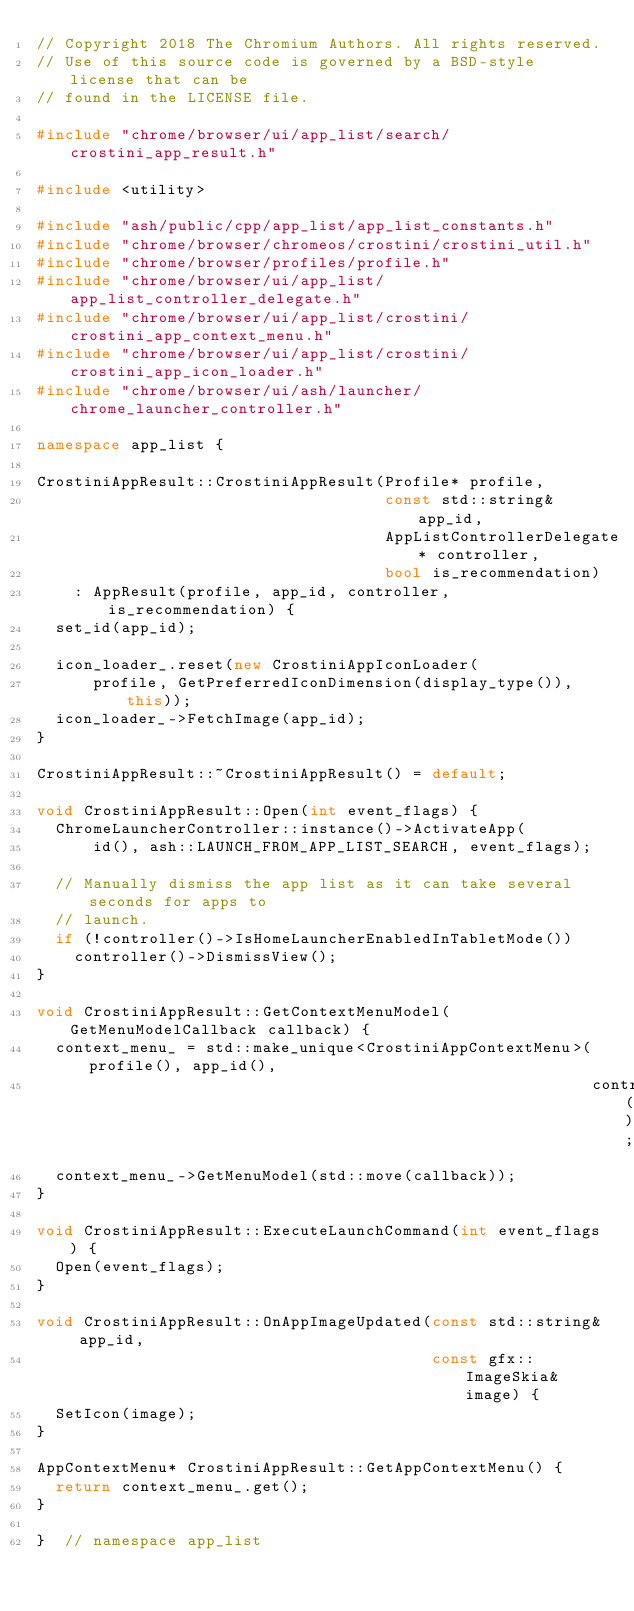<code> <loc_0><loc_0><loc_500><loc_500><_C++_>// Copyright 2018 The Chromium Authors. All rights reserved.
// Use of this source code is governed by a BSD-style license that can be
// found in the LICENSE file.

#include "chrome/browser/ui/app_list/search/crostini_app_result.h"

#include <utility>

#include "ash/public/cpp/app_list/app_list_constants.h"
#include "chrome/browser/chromeos/crostini/crostini_util.h"
#include "chrome/browser/profiles/profile.h"
#include "chrome/browser/ui/app_list/app_list_controller_delegate.h"
#include "chrome/browser/ui/app_list/crostini/crostini_app_context_menu.h"
#include "chrome/browser/ui/app_list/crostini/crostini_app_icon_loader.h"
#include "chrome/browser/ui/ash/launcher/chrome_launcher_controller.h"

namespace app_list {

CrostiniAppResult::CrostiniAppResult(Profile* profile,
                                     const std::string& app_id,
                                     AppListControllerDelegate* controller,
                                     bool is_recommendation)
    : AppResult(profile, app_id, controller, is_recommendation) {
  set_id(app_id);

  icon_loader_.reset(new CrostiniAppIconLoader(
      profile, GetPreferredIconDimension(display_type()), this));
  icon_loader_->FetchImage(app_id);
}

CrostiniAppResult::~CrostiniAppResult() = default;

void CrostiniAppResult::Open(int event_flags) {
  ChromeLauncherController::instance()->ActivateApp(
      id(), ash::LAUNCH_FROM_APP_LIST_SEARCH, event_flags);

  // Manually dismiss the app list as it can take several seconds for apps to
  // launch.
  if (!controller()->IsHomeLauncherEnabledInTabletMode())
    controller()->DismissView();
}

void CrostiniAppResult::GetContextMenuModel(GetMenuModelCallback callback) {
  context_menu_ = std::make_unique<CrostiniAppContextMenu>(profile(), app_id(),
                                                           controller());
  context_menu_->GetMenuModel(std::move(callback));
}

void CrostiniAppResult::ExecuteLaunchCommand(int event_flags) {
  Open(event_flags);
}

void CrostiniAppResult::OnAppImageUpdated(const std::string& app_id,
                                          const gfx::ImageSkia& image) {
  SetIcon(image);
}

AppContextMenu* CrostiniAppResult::GetAppContextMenu() {
  return context_menu_.get();
}

}  // namespace app_list
</code> 